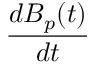Convert formula to latex. <formula><loc_0><loc_0><loc_500><loc_500>\frac { d B _ { p } ( t ) } { d t }</formula> 